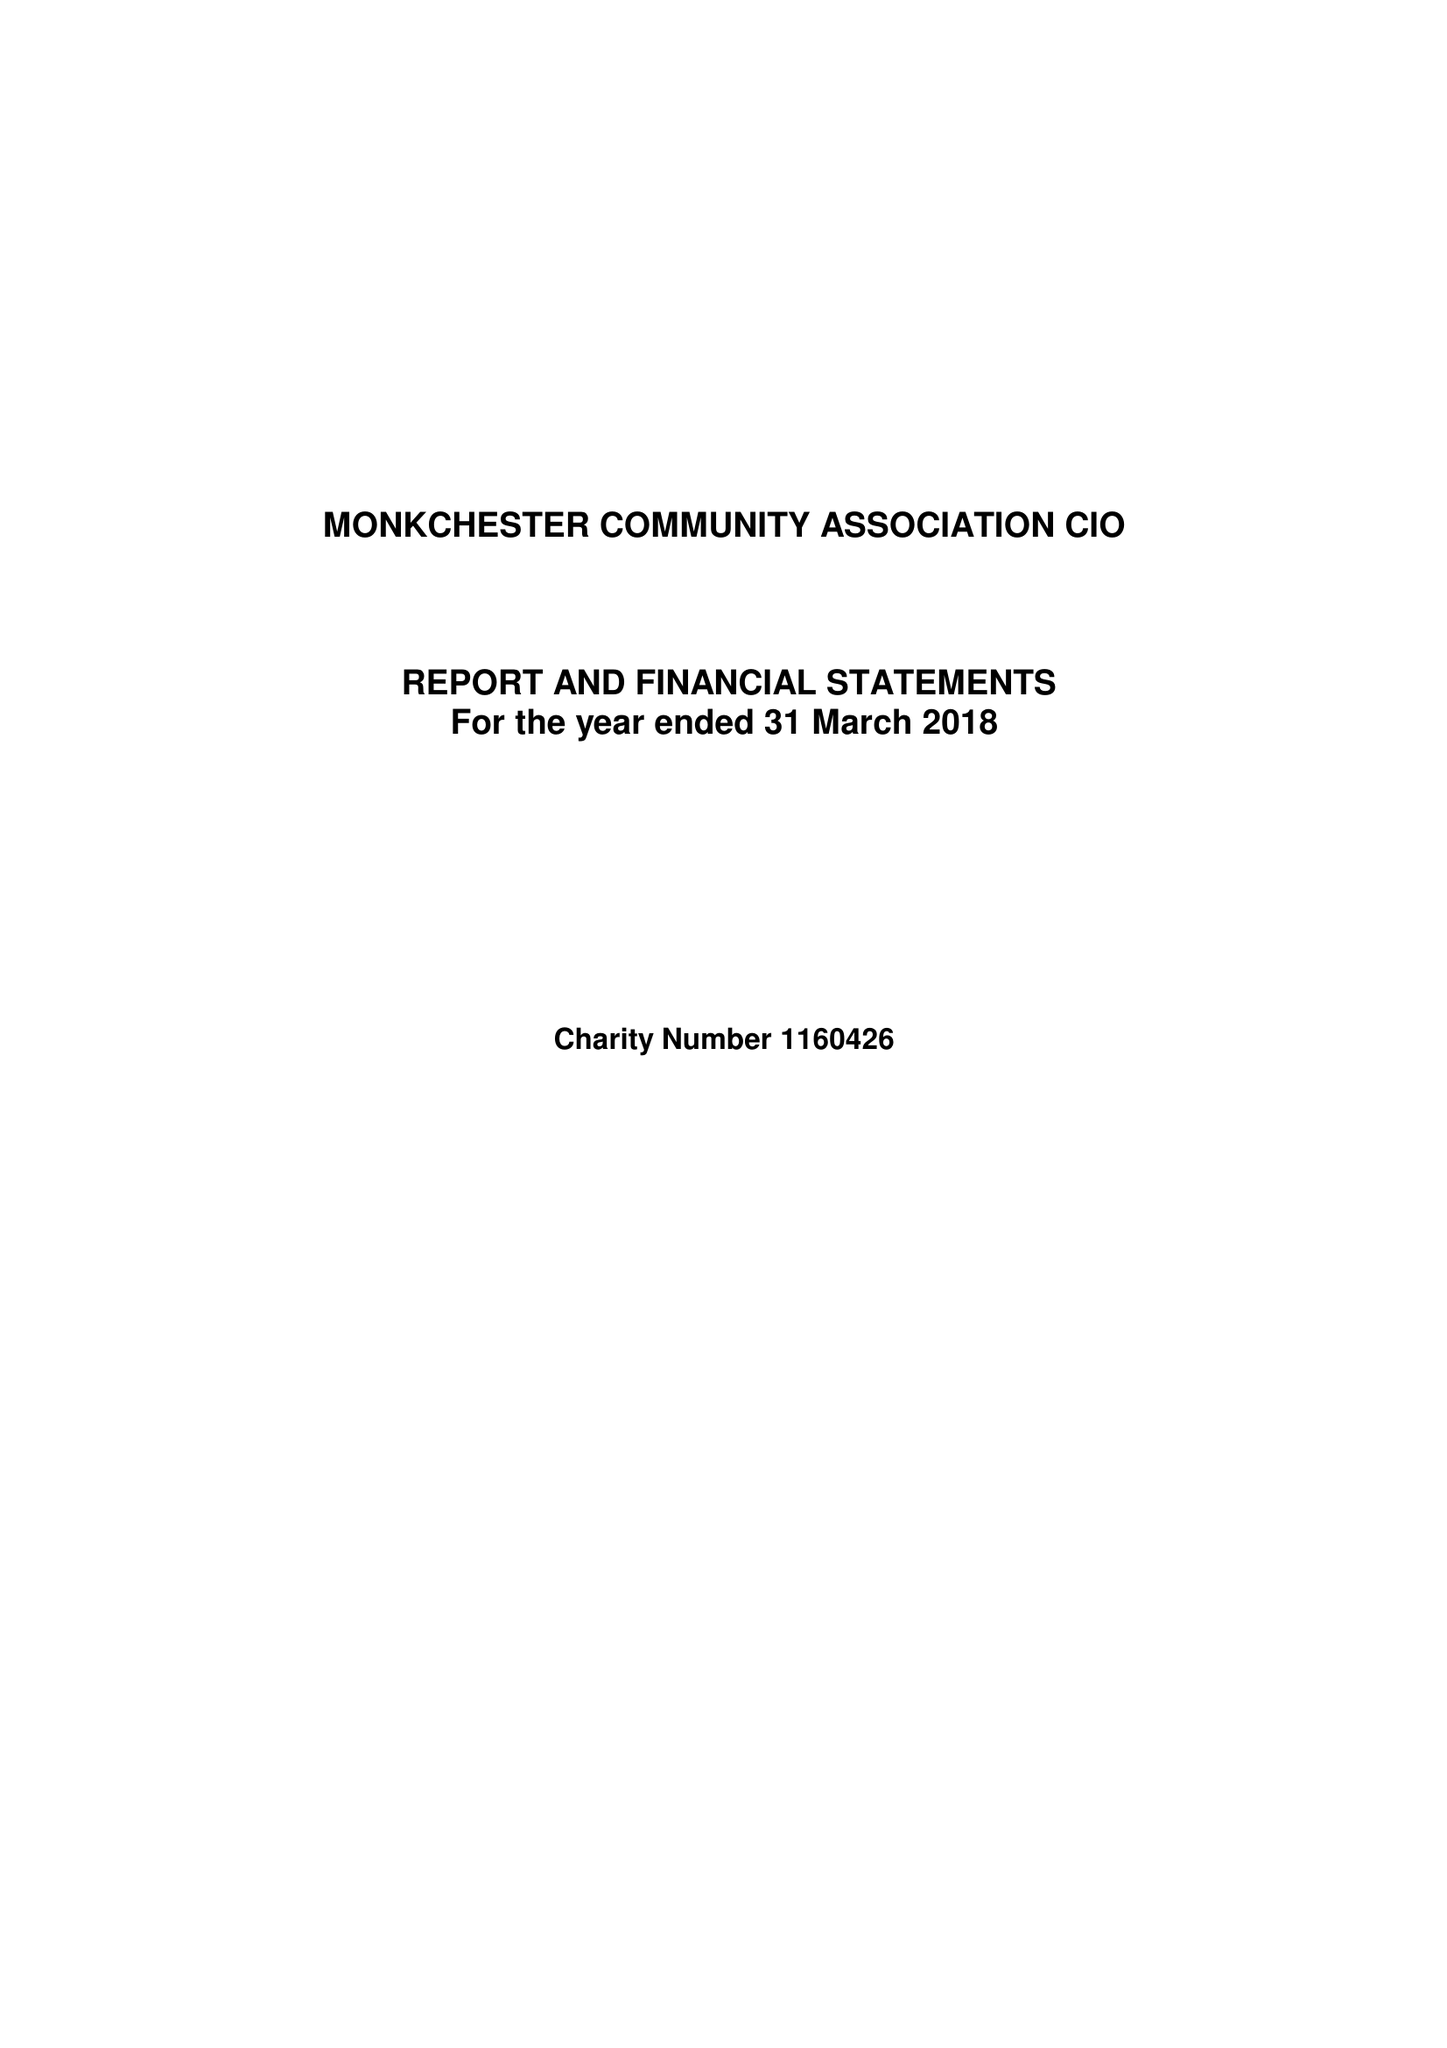What is the value for the charity_name?
Answer the question using a single word or phrase. Monkchester Community Association CIO 